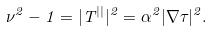<formula> <loc_0><loc_0><loc_500><loc_500>\nu ^ { 2 } - 1 = | T ^ { | | } | ^ { 2 } = \alpha ^ { 2 } | \nabla \tau | ^ { 2 } .</formula> 